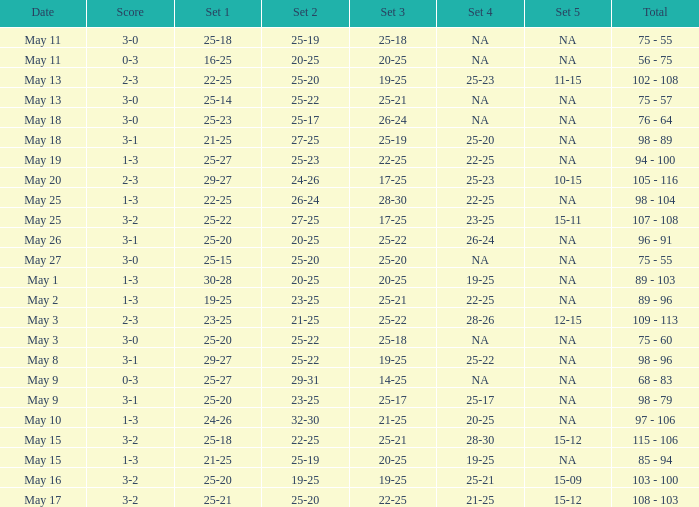Write the full table. {'header': ['Date', 'Score', 'Set 1', 'Set 2', 'Set 3', 'Set 4', 'Set 5', 'Total'], 'rows': [['May 11', '3-0', '25-18', '25-19', '25-18', 'NA', 'NA', '75 - 55'], ['May 11', '0-3', '16-25', '20-25', '20-25', 'NA', 'NA', '56 - 75'], ['May 13', '2-3', '22-25', '25-20', '19-25', '25-23', '11-15', '102 - 108'], ['May 13', '3-0', '25-14', '25-22', '25-21', 'NA', 'NA', '75 - 57'], ['May 18', '3-0', '25-23', '25-17', '26-24', 'NA', 'NA', '76 - 64'], ['May 18', '3-1', '21-25', '27-25', '25-19', '25-20', 'NA', '98 - 89'], ['May 19', '1-3', '25-27', '25-23', '22-25', '22-25', 'NA', '94 - 100'], ['May 20', '2-3', '29-27', '24-26', '17-25', '25-23', '10-15', '105 - 116'], ['May 25', '1-3', '22-25', '26-24', '28-30', '22-25', 'NA', '98 - 104'], ['May 25', '3-2', '25-22', '27-25', '17-25', '23-25', '15-11', '107 - 108'], ['May 26', '3-1', '25-20', '20-25', '25-22', '26-24', 'NA', '96 - 91'], ['May 27', '3-0', '25-15', '25-20', '25-20', 'NA', 'NA', '75 - 55'], ['May 1', '1-3', '30-28', '20-25', '20-25', '19-25', 'NA', '89 - 103'], ['May 2', '1-3', '19-25', '23-25', '25-21', '22-25', 'NA', '89 - 96'], ['May 3', '2-3', '23-25', '21-25', '25-22', '28-26', '12-15', '109 - 113'], ['May 3', '3-0', '25-20', '25-22', '25-18', 'NA', 'NA', '75 - 60'], ['May 8', '3-1', '29-27', '25-22', '19-25', '25-22', 'NA', '98 - 96'], ['May 9', '0-3', '25-27', '29-31', '14-25', 'NA', 'NA', '68 - 83'], ['May 9', '3-1', '25-20', '23-25', '25-17', '25-17', 'NA', '98 - 79'], ['May 10', '1-3', '24-26', '32-30', '21-25', '20-25', 'NA', '97 - 106'], ['May 15', '3-2', '25-18', '22-25', '25-21', '28-30', '15-12', '115 - 106'], ['May 15', '1-3', '21-25', '25-19', '20-25', '19-25', 'NA', '85 - 94'], ['May 16', '3-2', '25-20', '19-25', '19-25', '25-21', '15-09', '103 - 100'], ['May 17', '3-2', '25-21', '25-20', '22-25', '21-25', '15-12', '108 - 103']]} What does set 2 comprise of, with 1 set of 21-25, and 4 sets of 25-20? 27-25. 